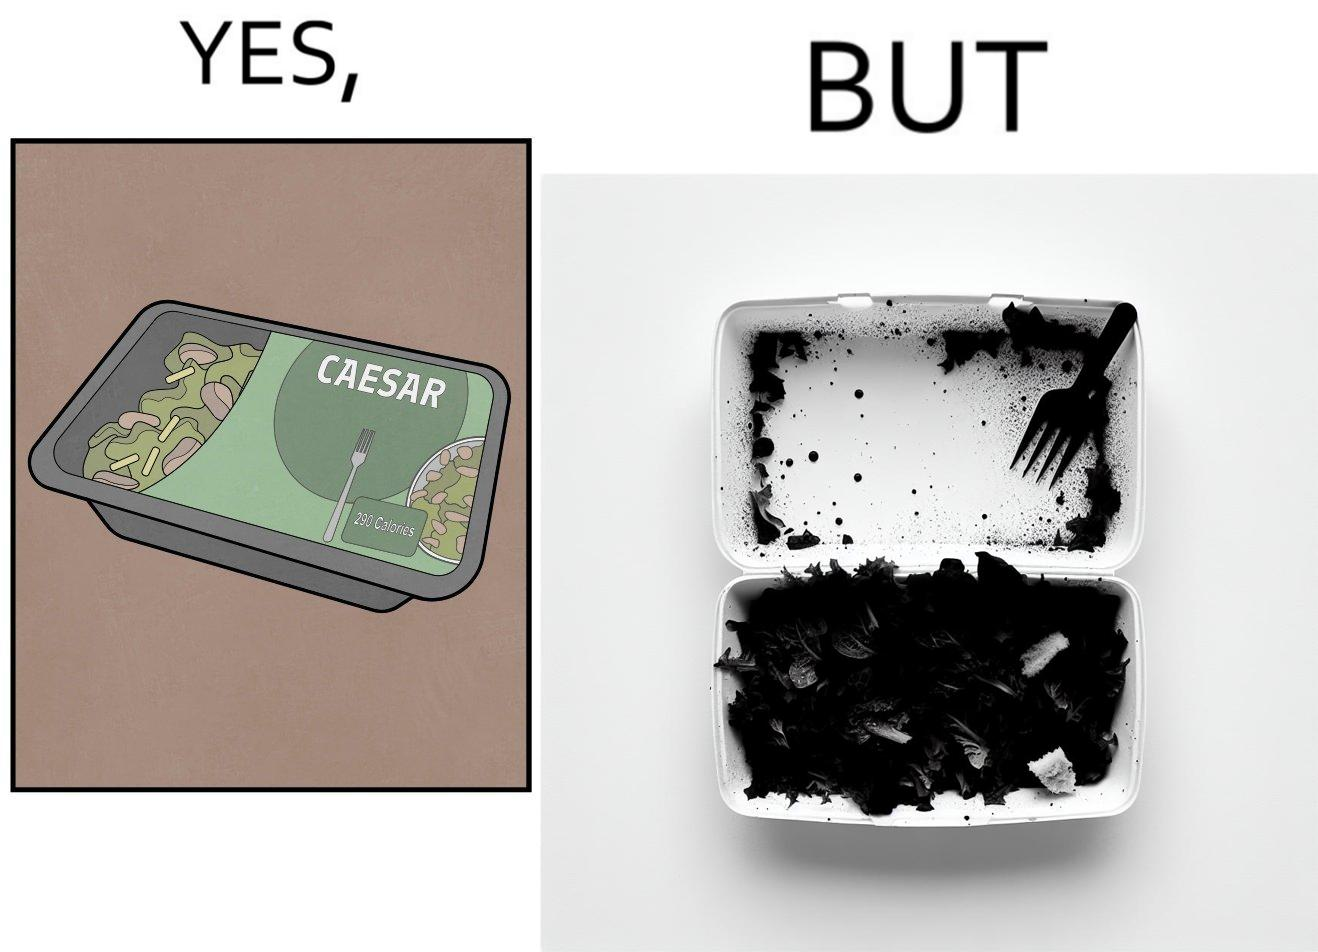Describe the content of this image. Image is funny because the box of salad was marketed in a way that showed a lot more salad content than was really present inside it. 